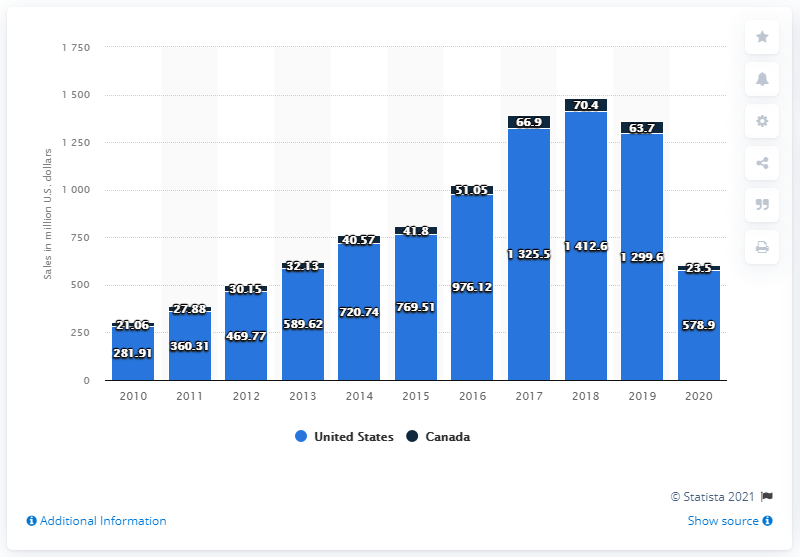Specify some key components in this picture. In 2020, the net sales of Samsonite in the United States totaled 578.9 million dollars. 